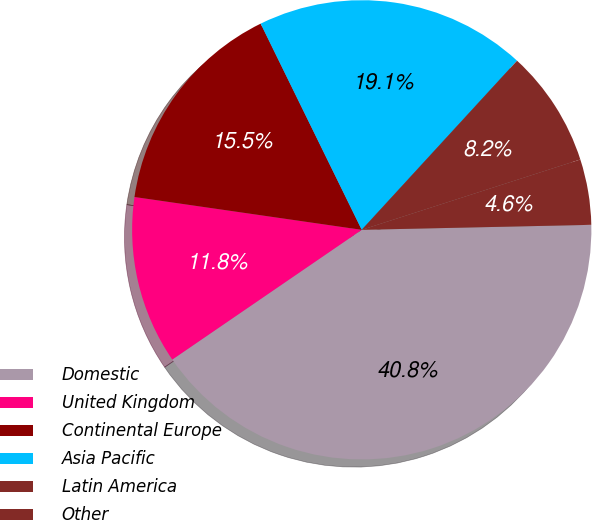Convert chart. <chart><loc_0><loc_0><loc_500><loc_500><pie_chart><fcel>Domestic<fcel>United Kingdom<fcel>Continental Europe<fcel>Asia Pacific<fcel>Latin America<fcel>Other<nl><fcel>40.79%<fcel>11.84%<fcel>15.46%<fcel>19.08%<fcel>8.22%<fcel>4.61%<nl></chart> 